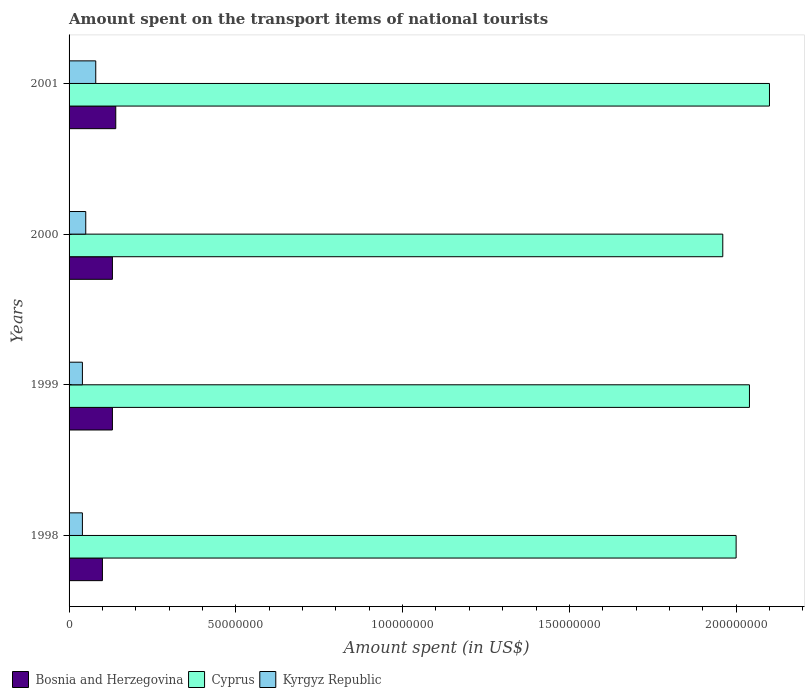Are the number of bars on each tick of the Y-axis equal?
Give a very brief answer. Yes. How many bars are there on the 2nd tick from the top?
Offer a terse response. 3. How many bars are there on the 4th tick from the bottom?
Provide a short and direct response. 3. In how many cases, is the number of bars for a given year not equal to the number of legend labels?
Your answer should be compact. 0. Across all years, what is the maximum amount spent on the transport items of national tourists in Cyprus?
Offer a terse response. 2.10e+08. What is the total amount spent on the transport items of national tourists in Kyrgyz Republic in the graph?
Provide a succinct answer. 2.10e+07. What is the difference between the amount spent on the transport items of national tourists in Cyprus in 1998 and that in 2000?
Your response must be concise. 4.00e+06. What is the difference between the amount spent on the transport items of national tourists in Kyrgyz Republic in 1999 and the amount spent on the transport items of national tourists in Cyprus in 2001?
Your answer should be very brief. -2.06e+08. What is the average amount spent on the transport items of national tourists in Kyrgyz Republic per year?
Your response must be concise. 5.25e+06. In the year 2001, what is the difference between the amount spent on the transport items of national tourists in Bosnia and Herzegovina and amount spent on the transport items of national tourists in Cyprus?
Your response must be concise. -1.96e+08. In how many years, is the amount spent on the transport items of national tourists in Cyprus greater than 20000000 US$?
Offer a very short reply. 4. What is the ratio of the amount spent on the transport items of national tourists in Cyprus in 1999 to that in 2000?
Give a very brief answer. 1.04. Is the amount spent on the transport items of national tourists in Cyprus in 1998 less than that in 2000?
Your answer should be compact. No. Is the difference between the amount spent on the transport items of national tourists in Bosnia and Herzegovina in 2000 and 2001 greater than the difference between the amount spent on the transport items of national tourists in Cyprus in 2000 and 2001?
Provide a short and direct response. Yes. What is the difference between the highest and the second highest amount spent on the transport items of national tourists in Bosnia and Herzegovina?
Provide a short and direct response. 1.00e+06. What does the 2nd bar from the top in 2000 represents?
Keep it short and to the point. Cyprus. What does the 1st bar from the bottom in 1998 represents?
Your answer should be very brief. Bosnia and Herzegovina. How many bars are there?
Ensure brevity in your answer.  12. What is the difference between two consecutive major ticks on the X-axis?
Offer a terse response. 5.00e+07. Are the values on the major ticks of X-axis written in scientific E-notation?
Your response must be concise. No. How many legend labels are there?
Keep it short and to the point. 3. How are the legend labels stacked?
Make the answer very short. Horizontal. What is the title of the graph?
Provide a short and direct response. Amount spent on the transport items of national tourists. What is the label or title of the X-axis?
Give a very brief answer. Amount spent (in US$). What is the Amount spent (in US$) in Bosnia and Herzegovina in 1998?
Give a very brief answer. 1.00e+07. What is the Amount spent (in US$) of Kyrgyz Republic in 1998?
Your response must be concise. 4.00e+06. What is the Amount spent (in US$) in Bosnia and Herzegovina in 1999?
Keep it short and to the point. 1.30e+07. What is the Amount spent (in US$) of Cyprus in 1999?
Give a very brief answer. 2.04e+08. What is the Amount spent (in US$) of Kyrgyz Republic in 1999?
Keep it short and to the point. 4.00e+06. What is the Amount spent (in US$) in Bosnia and Herzegovina in 2000?
Provide a succinct answer. 1.30e+07. What is the Amount spent (in US$) of Cyprus in 2000?
Provide a short and direct response. 1.96e+08. What is the Amount spent (in US$) of Bosnia and Herzegovina in 2001?
Your answer should be very brief. 1.40e+07. What is the Amount spent (in US$) of Cyprus in 2001?
Provide a short and direct response. 2.10e+08. What is the Amount spent (in US$) in Kyrgyz Republic in 2001?
Ensure brevity in your answer.  8.00e+06. Across all years, what is the maximum Amount spent (in US$) of Bosnia and Herzegovina?
Make the answer very short. 1.40e+07. Across all years, what is the maximum Amount spent (in US$) of Cyprus?
Provide a succinct answer. 2.10e+08. Across all years, what is the minimum Amount spent (in US$) of Bosnia and Herzegovina?
Make the answer very short. 1.00e+07. Across all years, what is the minimum Amount spent (in US$) in Cyprus?
Offer a very short reply. 1.96e+08. What is the total Amount spent (in US$) of Bosnia and Herzegovina in the graph?
Your answer should be very brief. 5.00e+07. What is the total Amount spent (in US$) in Cyprus in the graph?
Ensure brevity in your answer.  8.10e+08. What is the total Amount spent (in US$) of Kyrgyz Republic in the graph?
Make the answer very short. 2.10e+07. What is the difference between the Amount spent (in US$) of Bosnia and Herzegovina in 1998 and that in 1999?
Offer a very short reply. -3.00e+06. What is the difference between the Amount spent (in US$) in Kyrgyz Republic in 1998 and that in 1999?
Offer a very short reply. 0. What is the difference between the Amount spent (in US$) in Kyrgyz Republic in 1998 and that in 2000?
Keep it short and to the point. -1.00e+06. What is the difference between the Amount spent (in US$) in Bosnia and Herzegovina in 1998 and that in 2001?
Keep it short and to the point. -4.00e+06. What is the difference between the Amount spent (in US$) of Cyprus in 1998 and that in 2001?
Keep it short and to the point. -1.00e+07. What is the difference between the Amount spent (in US$) in Kyrgyz Republic in 1998 and that in 2001?
Provide a short and direct response. -4.00e+06. What is the difference between the Amount spent (in US$) of Bosnia and Herzegovina in 1999 and that in 2000?
Ensure brevity in your answer.  0. What is the difference between the Amount spent (in US$) in Cyprus in 1999 and that in 2001?
Provide a succinct answer. -6.00e+06. What is the difference between the Amount spent (in US$) of Kyrgyz Republic in 1999 and that in 2001?
Make the answer very short. -4.00e+06. What is the difference between the Amount spent (in US$) of Cyprus in 2000 and that in 2001?
Give a very brief answer. -1.40e+07. What is the difference between the Amount spent (in US$) in Bosnia and Herzegovina in 1998 and the Amount spent (in US$) in Cyprus in 1999?
Offer a terse response. -1.94e+08. What is the difference between the Amount spent (in US$) in Cyprus in 1998 and the Amount spent (in US$) in Kyrgyz Republic in 1999?
Your answer should be compact. 1.96e+08. What is the difference between the Amount spent (in US$) of Bosnia and Herzegovina in 1998 and the Amount spent (in US$) of Cyprus in 2000?
Offer a very short reply. -1.86e+08. What is the difference between the Amount spent (in US$) in Bosnia and Herzegovina in 1998 and the Amount spent (in US$) in Kyrgyz Republic in 2000?
Make the answer very short. 5.00e+06. What is the difference between the Amount spent (in US$) of Cyprus in 1998 and the Amount spent (in US$) of Kyrgyz Republic in 2000?
Make the answer very short. 1.95e+08. What is the difference between the Amount spent (in US$) of Bosnia and Herzegovina in 1998 and the Amount spent (in US$) of Cyprus in 2001?
Your answer should be compact. -2.00e+08. What is the difference between the Amount spent (in US$) of Bosnia and Herzegovina in 1998 and the Amount spent (in US$) of Kyrgyz Republic in 2001?
Your answer should be very brief. 2.00e+06. What is the difference between the Amount spent (in US$) of Cyprus in 1998 and the Amount spent (in US$) of Kyrgyz Republic in 2001?
Give a very brief answer. 1.92e+08. What is the difference between the Amount spent (in US$) of Bosnia and Herzegovina in 1999 and the Amount spent (in US$) of Cyprus in 2000?
Provide a succinct answer. -1.83e+08. What is the difference between the Amount spent (in US$) in Bosnia and Herzegovina in 1999 and the Amount spent (in US$) in Kyrgyz Republic in 2000?
Offer a terse response. 8.00e+06. What is the difference between the Amount spent (in US$) of Cyprus in 1999 and the Amount spent (in US$) of Kyrgyz Republic in 2000?
Ensure brevity in your answer.  1.99e+08. What is the difference between the Amount spent (in US$) in Bosnia and Herzegovina in 1999 and the Amount spent (in US$) in Cyprus in 2001?
Give a very brief answer. -1.97e+08. What is the difference between the Amount spent (in US$) in Cyprus in 1999 and the Amount spent (in US$) in Kyrgyz Republic in 2001?
Give a very brief answer. 1.96e+08. What is the difference between the Amount spent (in US$) of Bosnia and Herzegovina in 2000 and the Amount spent (in US$) of Cyprus in 2001?
Give a very brief answer. -1.97e+08. What is the difference between the Amount spent (in US$) of Bosnia and Herzegovina in 2000 and the Amount spent (in US$) of Kyrgyz Republic in 2001?
Ensure brevity in your answer.  5.00e+06. What is the difference between the Amount spent (in US$) in Cyprus in 2000 and the Amount spent (in US$) in Kyrgyz Republic in 2001?
Ensure brevity in your answer.  1.88e+08. What is the average Amount spent (in US$) in Bosnia and Herzegovina per year?
Keep it short and to the point. 1.25e+07. What is the average Amount spent (in US$) in Cyprus per year?
Make the answer very short. 2.02e+08. What is the average Amount spent (in US$) in Kyrgyz Republic per year?
Offer a very short reply. 5.25e+06. In the year 1998, what is the difference between the Amount spent (in US$) in Bosnia and Herzegovina and Amount spent (in US$) in Cyprus?
Provide a succinct answer. -1.90e+08. In the year 1998, what is the difference between the Amount spent (in US$) in Bosnia and Herzegovina and Amount spent (in US$) in Kyrgyz Republic?
Your response must be concise. 6.00e+06. In the year 1998, what is the difference between the Amount spent (in US$) of Cyprus and Amount spent (in US$) of Kyrgyz Republic?
Your answer should be very brief. 1.96e+08. In the year 1999, what is the difference between the Amount spent (in US$) in Bosnia and Herzegovina and Amount spent (in US$) in Cyprus?
Give a very brief answer. -1.91e+08. In the year 1999, what is the difference between the Amount spent (in US$) of Bosnia and Herzegovina and Amount spent (in US$) of Kyrgyz Republic?
Offer a very short reply. 9.00e+06. In the year 2000, what is the difference between the Amount spent (in US$) in Bosnia and Herzegovina and Amount spent (in US$) in Cyprus?
Provide a short and direct response. -1.83e+08. In the year 2000, what is the difference between the Amount spent (in US$) in Cyprus and Amount spent (in US$) in Kyrgyz Republic?
Your answer should be very brief. 1.91e+08. In the year 2001, what is the difference between the Amount spent (in US$) in Bosnia and Herzegovina and Amount spent (in US$) in Cyprus?
Keep it short and to the point. -1.96e+08. In the year 2001, what is the difference between the Amount spent (in US$) of Cyprus and Amount spent (in US$) of Kyrgyz Republic?
Offer a very short reply. 2.02e+08. What is the ratio of the Amount spent (in US$) in Bosnia and Herzegovina in 1998 to that in 1999?
Offer a very short reply. 0.77. What is the ratio of the Amount spent (in US$) of Cyprus in 1998 to that in 1999?
Offer a terse response. 0.98. What is the ratio of the Amount spent (in US$) of Bosnia and Herzegovina in 1998 to that in 2000?
Keep it short and to the point. 0.77. What is the ratio of the Amount spent (in US$) of Cyprus in 1998 to that in 2000?
Offer a very short reply. 1.02. What is the ratio of the Amount spent (in US$) in Kyrgyz Republic in 1998 to that in 2000?
Keep it short and to the point. 0.8. What is the ratio of the Amount spent (in US$) in Bosnia and Herzegovina in 1998 to that in 2001?
Provide a succinct answer. 0.71. What is the ratio of the Amount spent (in US$) in Kyrgyz Republic in 1998 to that in 2001?
Give a very brief answer. 0.5. What is the ratio of the Amount spent (in US$) of Bosnia and Herzegovina in 1999 to that in 2000?
Your response must be concise. 1. What is the ratio of the Amount spent (in US$) in Cyprus in 1999 to that in 2000?
Make the answer very short. 1.04. What is the ratio of the Amount spent (in US$) in Kyrgyz Republic in 1999 to that in 2000?
Ensure brevity in your answer.  0.8. What is the ratio of the Amount spent (in US$) of Bosnia and Herzegovina in 1999 to that in 2001?
Your answer should be compact. 0.93. What is the ratio of the Amount spent (in US$) in Cyprus in 1999 to that in 2001?
Offer a very short reply. 0.97. What is the ratio of the Amount spent (in US$) of Kyrgyz Republic in 1999 to that in 2001?
Your answer should be very brief. 0.5. What is the difference between the highest and the second highest Amount spent (in US$) of Kyrgyz Republic?
Provide a succinct answer. 3.00e+06. What is the difference between the highest and the lowest Amount spent (in US$) in Bosnia and Herzegovina?
Offer a terse response. 4.00e+06. What is the difference between the highest and the lowest Amount spent (in US$) of Cyprus?
Provide a short and direct response. 1.40e+07. 